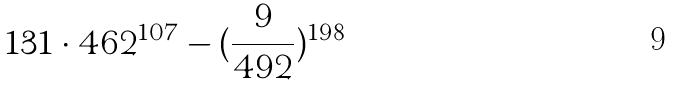Convert formula to latex. <formula><loc_0><loc_0><loc_500><loc_500>1 3 1 \cdot 4 6 2 ^ { 1 0 7 } - ( \frac { 9 } { 4 9 2 } ) ^ { 1 9 8 }</formula> 